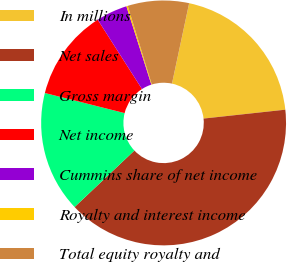<chart> <loc_0><loc_0><loc_500><loc_500><pie_chart><fcel>In millions<fcel>Net sales<fcel>Gross margin<fcel>Net income<fcel>Cummins share of net income<fcel>Royalty and interest income<fcel>Total equity royalty and<nl><fcel>19.93%<fcel>39.68%<fcel>15.98%<fcel>12.03%<fcel>4.13%<fcel>0.18%<fcel>8.08%<nl></chart> 